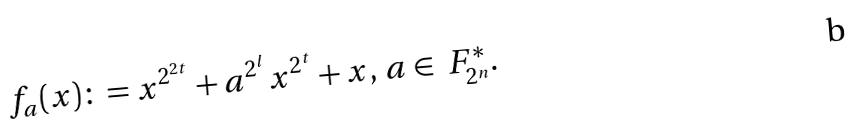Convert formula to latex. <formula><loc_0><loc_0><loc_500><loc_500>f _ { a } ( x ) \colon = x ^ { 2 ^ { 2 t } } + a ^ { 2 ^ { l } } x ^ { 2 ^ { t } } + x , \, a \in \ F _ { 2 ^ { n } } ^ { * } .</formula> 